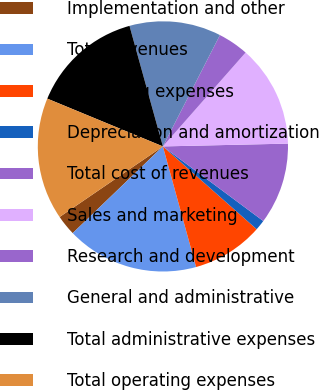<chart> <loc_0><loc_0><loc_500><loc_500><pie_chart><fcel>Implementation and other<fcel>Total revenues<fcel>Operating expenses<fcel>Depreciation and amortization<fcel>Total cost of revenues<fcel>Sales and marketing<fcel>Research and development<fcel>General and administrative<fcel>Total administrative expenses<fcel>Total operating expenses<nl><fcel>2.65%<fcel>17.09%<fcel>9.21%<fcel>1.34%<fcel>10.53%<fcel>13.15%<fcel>3.96%<fcel>11.84%<fcel>14.46%<fcel>15.78%<nl></chart> 